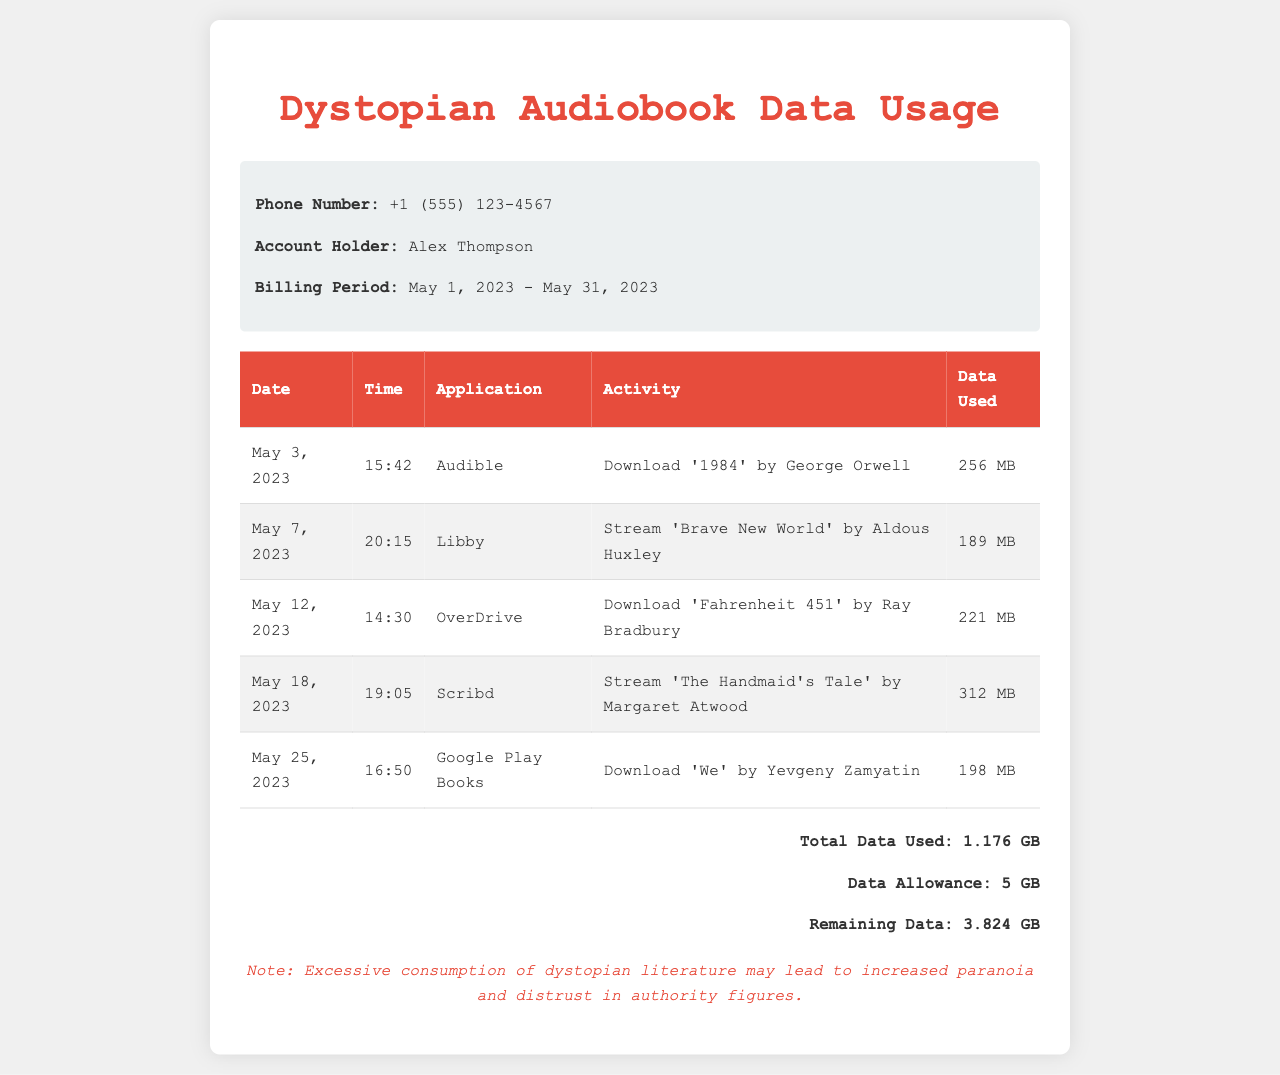What is the phone number of the account holder? The phone number is provided in the information section of the document.
Answer: +1 (555) 123-4567 Who is the account holder? The name of the account holder is listed in the information section.
Answer: Alex Thompson What is the billing period? The billing period is explicitly stated in the document.
Answer: May 1, 2023 - May 31, 2023 How much data was used to stream 'The Handmaid's Tale'? The data used for streaming this audiobook is mentioned in the table.
Answer: 312 MB What is the total data used during the billing period? The total data used is summarized at the bottom of the document.
Answer: 1.176 GB Which application was used to download '1984'? The document specifies which application was used for each activity.
Answer: Audible What is the remaining data allowance after usage? The remaining data is listed in the summary section.
Answer: 3.824 GB What was the activity on May 12, 2023? The document describes activities including dates in the table.
Answer: Download 'Fahrenheit 451' by Ray Bradbury Which dystopian novel was streamed on May 7, 2023? The specific titles streamed or downloaded are detailed in the activity column.
Answer: 'Brave New World' by Aldous Huxley 